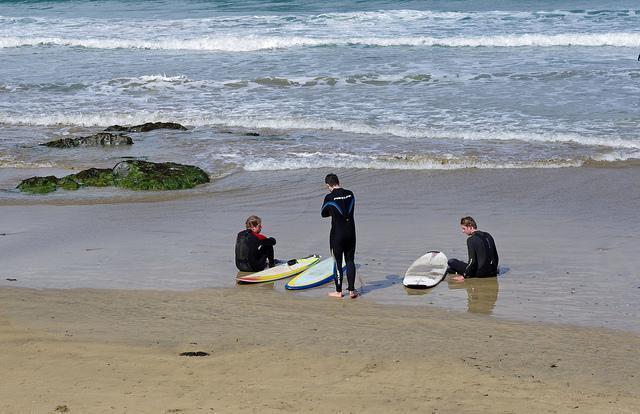What is the green substance near the shoreline?
Choose the correct response, then elucidate: 'Answer: answer
Rationale: rationale.'
Options: Shellfish, plastic, moss, dirt. Answer: moss.
Rationale: This is a moss that grows in wet area because of water. 